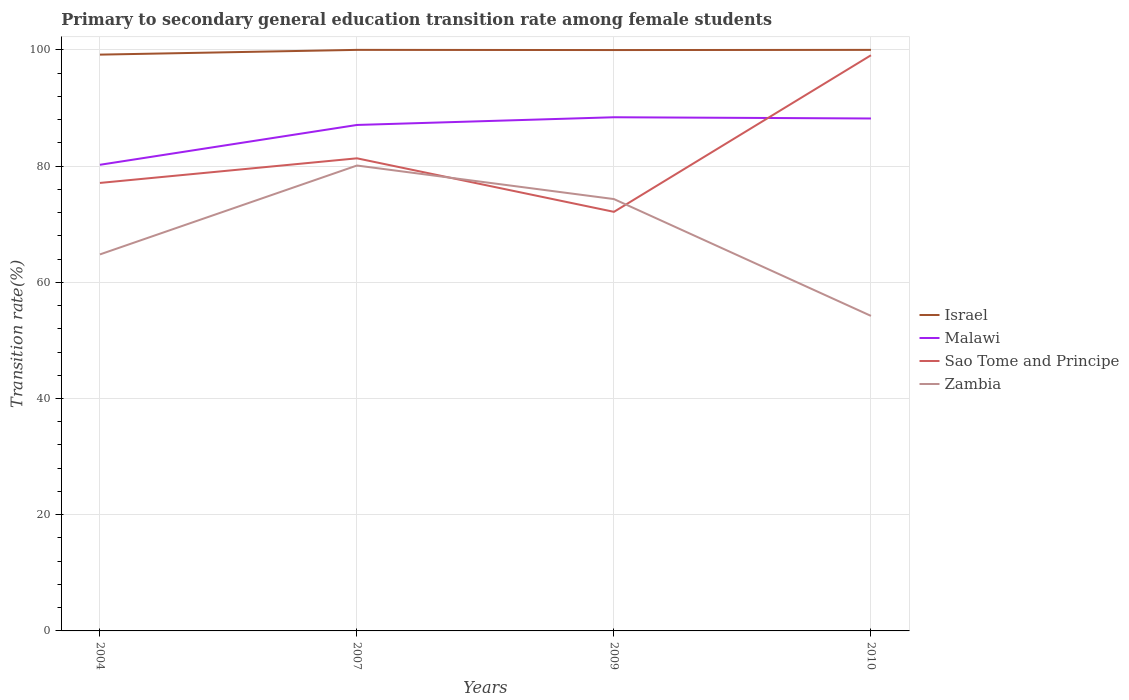Across all years, what is the maximum transition rate in Sao Tome and Principe?
Give a very brief answer. 72.12. What is the total transition rate in Malawi in the graph?
Provide a succinct answer. -1.11. What is the difference between the highest and the second highest transition rate in Sao Tome and Principe?
Your answer should be compact. 26.95. What is the difference between the highest and the lowest transition rate in Malawi?
Offer a very short reply. 3. How many years are there in the graph?
Make the answer very short. 4. Does the graph contain any zero values?
Provide a succinct answer. No. Does the graph contain grids?
Give a very brief answer. Yes. Where does the legend appear in the graph?
Provide a short and direct response. Center right. How many legend labels are there?
Make the answer very short. 4. What is the title of the graph?
Make the answer very short. Primary to secondary general education transition rate among female students. Does "Lithuania" appear as one of the legend labels in the graph?
Offer a terse response. No. What is the label or title of the X-axis?
Make the answer very short. Years. What is the label or title of the Y-axis?
Offer a terse response. Transition rate(%). What is the Transition rate(%) of Israel in 2004?
Ensure brevity in your answer.  99.18. What is the Transition rate(%) in Malawi in 2004?
Provide a succinct answer. 80.22. What is the Transition rate(%) in Sao Tome and Principe in 2004?
Provide a succinct answer. 77.1. What is the Transition rate(%) of Zambia in 2004?
Make the answer very short. 64.8. What is the Transition rate(%) in Israel in 2007?
Offer a very short reply. 100. What is the Transition rate(%) in Malawi in 2007?
Make the answer very short. 87.08. What is the Transition rate(%) in Sao Tome and Principe in 2007?
Offer a terse response. 81.34. What is the Transition rate(%) in Zambia in 2007?
Give a very brief answer. 80.1. What is the Transition rate(%) in Israel in 2009?
Ensure brevity in your answer.  99.97. What is the Transition rate(%) in Malawi in 2009?
Provide a succinct answer. 88.4. What is the Transition rate(%) of Sao Tome and Principe in 2009?
Offer a terse response. 72.12. What is the Transition rate(%) of Zambia in 2009?
Provide a succinct answer. 74.32. What is the Transition rate(%) of Israel in 2010?
Provide a succinct answer. 100. What is the Transition rate(%) of Malawi in 2010?
Offer a terse response. 88.19. What is the Transition rate(%) in Sao Tome and Principe in 2010?
Give a very brief answer. 99.07. What is the Transition rate(%) of Zambia in 2010?
Ensure brevity in your answer.  54.22. Across all years, what is the maximum Transition rate(%) in Israel?
Provide a short and direct response. 100. Across all years, what is the maximum Transition rate(%) in Malawi?
Your answer should be very brief. 88.4. Across all years, what is the maximum Transition rate(%) of Sao Tome and Principe?
Provide a short and direct response. 99.07. Across all years, what is the maximum Transition rate(%) of Zambia?
Keep it short and to the point. 80.1. Across all years, what is the minimum Transition rate(%) in Israel?
Give a very brief answer. 99.18. Across all years, what is the minimum Transition rate(%) of Malawi?
Ensure brevity in your answer.  80.22. Across all years, what is the minimum Transition rate(%) of Sao Tome and Principe?
Offer a terse response. 72.12. Across all years, what is the minimum Transition rate(%) of Zambia?
Provide a short and direct response. 54.22. What is the total Transition rate(%) of Israel in the graph?
Your response must be concise. 399.15. What is the total Transition rate(%) in Malawi in the graph?
Keep it short and to the point. 343.9. What is the total Transition rate(%) in Sao Tome and Principe in the graph?
Make the answer very short. 329.64. What is the total Transition rate(%) of Zambia in the graph?
Give a very brief answer. 273.44. What is the difference between the Transition rate(%) in Israel in 2004 and that in 2007?
Offer a very short reply. -0.82. What is the difference between the Transition rate(%) in Malawi in 2004 and that in 2007?
Keep it short and to the point. -6.85. What is the difference between the Transition rate(%) in Sao Tome and Principe in 2004 and that in 2007?
Your answer should be compact. -4.24. What is the difference between the Transition rate(%) of Zambia in 2004 and that in 2007?
Give a very brief answer. -15.3. What is the difference between the Transition rate(%) of Israel in 2004 and that in 2009?
Provide a succinct answer. -0.79. What is the difference between the Transition rate(%) of Malawi in 2004 and that in 2009?
Offer a very short reply. -8.18. What is the difference between the Transition rate(%) of Sao Tome and Principe in 2004 and that in 2009?
Keep it short and to the point. 4.98. What is the difference between the Transition rate(%) in Zambia in 2004 and that in 2009?
Ensure brevity in your answer.  -9.52. What is the difference between the Transition rate(%) of Israel in 2004 and that in 2010?
Keep it short and to the point. -0.82. What is the difference between the Transition rate(%) of Malawi in 2004 and that in 2010?
Make the answer very short. -7.97. What is the difference between the Transition rate(%) of Sao Tome and Principe in 2004 and that in 2010?
Make the answer very short. -21.97. What is the difference between the Transition rate(%) of Zambia in 2004 and that in 2010?
Keep it short and to the point. 10.58. What is the difference between the Transition rate(%) in Israel in 2007 and that in 2009?
Provide a short and direct response. 0.03. What is the difference between the Transition rate(%) in Malawi in 2007 and that in 2009?
Provide a short and direct response. -1.33. What is the difference between the Transition rate(%) in Sao Tome and Principe in 2007 and that in 2009?
Give a very brief answer. 9.21. What is the difference between the Transition rate(%) of Zambia in 2007 and that in 2009?
Offer a very short reply. 5.77. What is the difference between the Transition rate(%) of Malawi in 2007 and that in 2010?
Your answer should be very brief. -1.11. What is the difference between the Transition rate(%) in Sao Tome and Principe in 2007 and that in 2010?
Your answer should be very brief. -17.74. What is the difference between the Transition rate(%) in Zambia in 2007 and that in 2010?
Offer a very short reply. 25.88. What is the difference between the Transition rate(%) in Israel in 2009 and that in 2010?
Make the answer very short. -0.03. What is the difference between the Transition rate(%) in Malawi in 2009 and that in 2010?
Keep it short and to the point. 0.21. What is the difference between the Transition rate(%) of Sao Tome and Principe in 2009 and that in 2010?
Keep it short and to the point. -26.95. What is the difference between the Transition rate(%) of Zambia in 2009 and that in 2010?
Offer a terse response. 20.1. What is the difference between the Transition rate(%) in Israel in 2004 and the Transition rate(%) in Malawi in 2007?
Give a very brief answer. 12.11. What is the difference between the Transition rate(%) of Israel in 2004 and the Transition rate(%) of Sao Tome and Principe in 2007?
Your answer should be very brief. 17.85. What is the difference between the Transition rate(%) in Israel in 2004 and the Transition rate(%) in Zambia in 2007?
Your answer should be very brief. 19.09. What is the difference between the Transition rate(%) in Malawi in 2004 and the Transition rate(%) in Sao Tome and Principe in 2007?
Give a very brief answer. -1.11. What is the difference between the Transition rate(%) in Malawi in 2004 and the Transition rate(%) in Zambia in 2007?
Give a very brief answer. 0.13. What is the difference between the Transition rate(%) of Sao Tome and Principe in 2004 and the Transition rate(%) of Zambia in 2007?
Ensure brevity in your answer.  -3. What is the difference between the Transition rate(%) in Israel in 2004 and the Transition rate(%) in Malawi in 2009?
Keep it short and to the point. 10.78. What is the difference between the Transition rate(%) in Israel in 2004 and the Transition rate(%) in Sao Tome and Principe in 2009?
Provide a short and direct response. 27.06. What is the difference between the Transition rate(%) of Israel in 2004 and the Transition rate(%) of Zambia in 2009?
Offer a very short reply. 24.86. What is the difference between the Transition rate(%) in Malawi in 2004 and the Transition rate(%) in Sao Tome and Principe in 2009?
Your answer should be very brief. 8.1. What is the difference between the Transition rate(%) in Malawi in 2004 and the Transition rate(%) in Zambia in 2009?
Your answer should be very brief. 5.9. What is the difference between the Transition rate(%) in Sao Tome and Principe in 2004 and the Transition rate(%) in Zambia in 2009?
Give a very brief answer. 2.78. What is the difference between the Transition rate(%) of Israel in 2004 and the Transition rate(%) of Malawi in 2010?
Provide a succinct answer. 10.99. What is the difference between the Transition rate(%) of Israel in 2004 and the Transition rate(%) of Sao Tome and Principe in 2010?
Ensure brevity in your answer.  0.11. What is the difference between the Transition rate(%) in Israel in 2004 and the Transition rate(%) in Zambia in 2010?
Your answer should be compact. 44.96. What is the difference between the Transition rate(%) in Malawi in 2004 and the Transition rate(%) in Sao Tome and Principe in 2010?
Provide a short and direct response. -18.85. What is the difference between the Transition rate(%) of Malawi in 2004 and the Transition rate(%) of Zambia in 2010?
Give a very brief answer. 26. What is the difference between the Transition rate(%) in Sao Tome and Principe in 2004 and the Transition rate(%) in Zambia in 2010?
Offer a terse response. 22.88. What is the difference between the Transition rate(%) in Israel in 2007 and the Transition rate(%) in Malawi in 2009?
Your answer should be very brief. 11.6. What is the difference between the Transition rate(%) of Israel in 2007 and the Transition rate(%) of Sao Tome and Principe in 2009?
Keep it short and to the point. 27.88. What is the difference between the Transition rate(%) of Israel in 2007 and the Transition rate(%) of Zambia in 2009?
Give a very brief answer. 25.68. What is the difference between the Transition rate(%) in Malawi in 2007 and the Transition rate(%) in Sao Tome and Principe in 2009?
Your answer should be very brief. 14.95. What is the difference between the Transition rate(%) of Malawi in 2007 and the Transition rate(%) of Zambia in 2009?
Offer a very short reply. 12.76. What is the difference between the Transition rate(%) of Sao Tome and Principe in 2007 and the Transition rate(%) of Zambia in 2009?
Provide a succinct answer. 7.02. What is the difference between the Transition rate(%) of Israel in 2007 and the Transition rate(%) of Malawi in 2010?
Your response must be concise. 11.81. What is the difference between the Transition rate(%) of Israel in 2007 and the Transition rate(%) of Sao Tome and Principe in 2010?
Give a very brief answer. 0.93. What is the difference between the Transition rate(%) in Israel in 2007 and the Transition rate(%) in Zambia in 2010?
Your answer should be very brief. 45.78. What is the difference between the Transition rate(%) in Malawi in 2007 and the Transition rate(%) in Sao Tome and Principe in 2010?
Keep it short and to the point. -12. What is the difference between the Transition rate(%) in Malawi in 2007 and the Transition rate(%) in Zambia in 2010?
Offer a very short reply. 32.86. What is the difference between the Transition rate(%) in Sao Tome and Principe in 2007 and the Transition rate(%) in Zambia in 2010?
Provide a short and direct response. 27.12. What is the difference between the Transition rate(%) in Israel in 2009 and the Transition rate(%) in Malawi in 2010?
Make the answer very short. 11.78. What is the difference between the Transition rate(%) of Israel in 2009 and the Transition rate(%) of Sao Tome and Principe in 2010?
Provide a succinct answer. 0.9. What is the difference between the Transition rate(%) of Israel in 2009 and the Transition rate(%) of Zambia in 2010?
Give a very brief answer. 45.75. What is the difference between the Transition rate(%) of Malawi in 2009 and the Transition rate(%) of Sao Tome and Principe in 2010?
Your answer should be compact. -10.67. What is the difference between the Transition rate(%) of Malawi in 2009 and the Transition rate(%) of Zambia in 2010?
Your response must be concise. 34.18. What is the difference between the Transition rate(%) in Sao Tome and Principe in 2009 and the Transition rate(%) in Zambia in 2010?
Provide a short and direct response. 17.91. What is the average Transition rate(%) in Israel per year?
Give a very brief answer. 99.79. What is the average Transition rate(%) in Malawi per year?
Offer a very short reply. 85.97. What is the average Transition rate(%) in Sao Tome and Principe per year?
Your response must be concise. 82.41. What is the average Transition rate(%) in Zambia per year?
Offer a terse response. 68.36. In the year 2004, what is the difference between the Transition rate(%) of Israel and Transition rate(%) of Malawi?
Ensure brevity in your answer.  18.96. In the year 2004, what is the difference between the Transition rate(%) in Israel and Transition rate(%) in Sao Tome and Principe?
Your answer should be very brief. 22.08. In the year 2004, what is the difference between the Transition rate(%) of Israel and Transition rate(%) of Zambia?
Provide a succinct answer. 34.38. In the year 2004, what is the difference between the Transition rate(%) of Malawi and Transition rate(%) of Sao Tome and Principe?
Provide a short and direct response. 3.12. In the year 2004, what is the difference between the Transition rate(%) in Malawi and Transition rate(%) in Zambia?
Provide a short and direct response. 15.42. In the year 2004, what is the difference between the Transition rate(%) in Sao Tome and Principe and Transition rate(%) in Zambia?
Keep it short and to the point. 12.3. In the year 2007, what is the difference between the Transition rate(%) of Israel and Transition rate(%) of Malawi?
Give a very brief answer. 12.92. In the year 2007, what is the difference between the Transition rate(%) in Israel and Transition rate(%) in Sao Tome and Principe?
Provide a succinct answer. 18.66. In the year 2007, what is the difference between the Transition rate(%) of Israel and Transition rate(%) of Zambia?
Provide a short and direct response. 19.9. In the year 2007, what is the difference between the Transition rate(%) in Malawi and Transition rate(%) in Sao Tome and Principe?
Provide a short and direct response. 5.74. In the year 2007, what is the difference between the Transition rate(%) in Malawi and Transition rate(%) in Zambia?
Give a very brief answer. 6.98. In the year 2007, what is the difference between the Transition rate(%) of Sao Tome and Principe and Transition rate(%) of Zambia?
Make the answer very short. 1.24. In the year 2009, what is the difference between the Transition rate(%) in Israel and Transition rate(%) in Malawi?
Give a very brief answer. 11.57. In the year 2009, what is the difference between the Transition rate(%) of Israel and Transition rate(%) of Sao Tome and Principe?
Provide a short and direct response. 27.85. In the year 2009, what is the difference between the Transition rate(%) in Israel and Transition rate(%) in Zambia?
Your response must be concise. 25.65. In the year 2009, what is the difference between the Transition rate(%) in Malawi and Transition rate(%) in Sao Tome and Principe?
Offer a terse response. 16.28. In the year 2009, what is the difference between the Transition rate(%) of Malawi and Transition rate(%) of Zambia?
Provide a succinct answer. 14.08. In the year 2009, what is the difference between the Transition rate(%) in Sao Tome and Principe and Transition rate(%) in Zambia?
Provide a succinct answer. -2.2. In the year 2010, what is the difference between the Transition rate(%) in Israel and Transition rate(%) in Malawi?
Provide a short and direct response. 11.81. In the year 2010, what is the difference between the Transition rate(%) of Israel and Transition rate(%) of Sao Tome and Principe?
Ensure brevity in your answer.  0.93. In the year 2010, what is the difference between the Transition rate(%) of Israel and Transition rate(%) of Zambia?
Offer a terse response. 45.78. In the year 2010, what is the difference between the Transition rate(%) of Malawi and Transition rate(%) of Sao Tome and Principe?
Offer a very short reply. -10.88. In the year 2010, what is the difference between the Transition rate(%) in Malawi and Transition rate(%) in Zambia?
Offer a very short reply. 33.97. In the year 2010, what is the difference between the Transition rate(%) in Sao Tome and Principe and Transition rate(%) in Zambia?
Make the answer very short. 44.86. What is the ratio of the Transition rate(%) of Malawi in 2004 to that in 2007?
Offer a very short reply. 0.92. What is the ratio of the Transition rate(%) in Sao Tome and Principe in 2004 to that in 2007?
Make the answer very short. 0.95. What is the ratio of the Transition rate(%) in Zambia in 2004 to that in 2007?
Keep it short and to the point. 0.81. What is the ratio of the Transition rate(%) in Malawi in 2004 to that in 2009?
Offer a very short reply. 0.91. What is the ratio of the Transition rate(%) of Sao Tome and Principe in 2004 to that in 2009?
Your answer should be very brief. 1.07. What is the ratio of the Transition rate(%) in Zambia in 2004 to that in 2009?
Ensure brevity in your answer.  0.87. What is the ratio of the Transition rate(%) in Malawi in 2004 to that in 2010?
Provide a succinct answer. 0.91. What is the ratio of the Transition rate(%) of Sao Tome and Principe in 2004 to that in 2010?
Provide a short and direct response. 0.78. What is the ratio of the Transition rate(%) in Zambia in 2004 to that in 2010?
Make the answer very short. 1.2. What is the ratio of the Transition rate(%) of Malawi in 2007 to that in 2009?
Your answer should be very brief. 0.98. What is the ratio of the Transition rate(%) of Sao Tome and Principe in 2007 to that in 2009?
Keep it short and to the point. 1.13. What is the ratio of the Transition rate(%) of Zambia in 2007 to that in 2009?
Your answer should be very brief. 1.08. What is the ratio of the Transition rate(%) of Malawi in 2007 to that in 2010?
Offer a terse response. 0.99. What is the ratio of the Transition rate(%) of Sao Tome and Principe in 2007 to that in 2010?
Your response must be concise. 0.82. What is the ratio of the Transition rate(%) in Zambia in 2007 to that in 2010?
Provide a short and direct response. 1.48. What is the ratio of the Transition rate(%) of Israel in 2009 to that in 2010?
Keep it short and to the point. 1. What is the ratio of the Transition rate(%) in Malawi in 2009 to that in 2010?
Your response must be concise. 1. What is the ratio of the Transition rate(%) of Sao Tome and Principe in 2009 to that in 2010?
Ensure brevity in your answer.  0.73. What is the ratio of the Transition rate(%) in Zambia in 2009 to that in 2010?
Ensure brevity in your answer.  1.37. What is the difference between the highest and the second highest Transition rate(%) in Israel?
Keep it short and to the point. 0. What is the difference between the highest and the second highest Transition rate(%) in Malawi?
Keep it short and to the point. 0.21. What is the difference between the highest and the second highest Transition rate(%) of Sao Tome and Principe?
Provide a succinct answer. 17.74. What is the difference between the highest and the second highest Transition rate(%) of Zambia?
Your answer should be very brief. 5.77. What is the difference between the highest and the lowest Transition rate(%) of Israel?
Give a very brief answer. 0.82. What is the difference between the highest and the lowest Transition rate(%) of Malawi?
Provide a succinct answer. 8.18. What is the difference between the highest and the lowest Transition rate(%) in Sao Tome and Principe?
Provide a short and direct response. 26.95. What is the difference between the highest and the lowest Transition rate(%) of Zambia?
Provide a succinct answer. 25.88. 